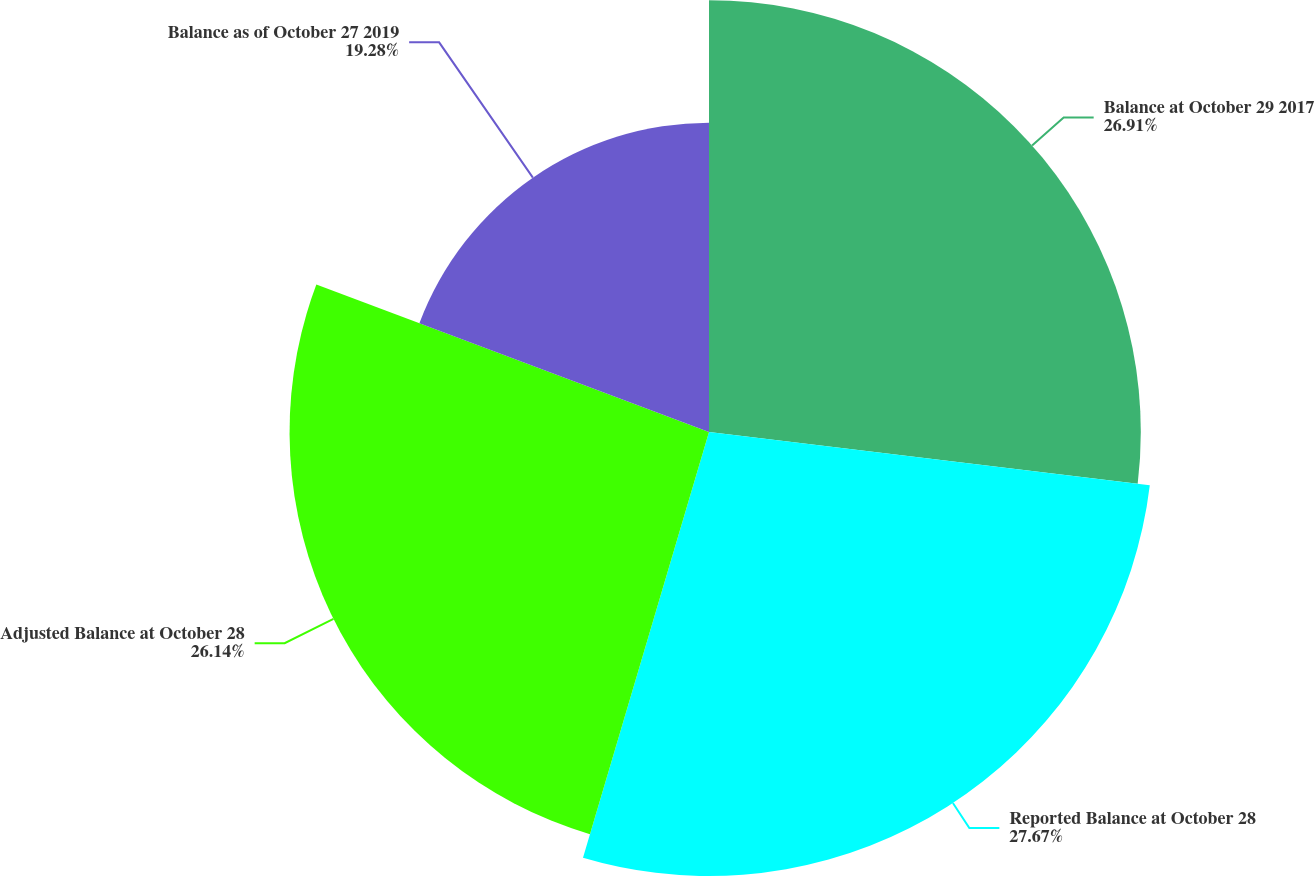Convert chart to OTSL. <chart><loc_0><loc_0><loc_500><loc_500><pie_chart><fcel>Balance at October 29 2017<fcel>Reported Balance at October 28<fcel>Adjusted Balance at October 28<fcel>Balance as of October 27 2019<nl><fcel>26.91%<fcel>27.67%<fcel>26.14%<fcel>19.28%<nl></chart> 